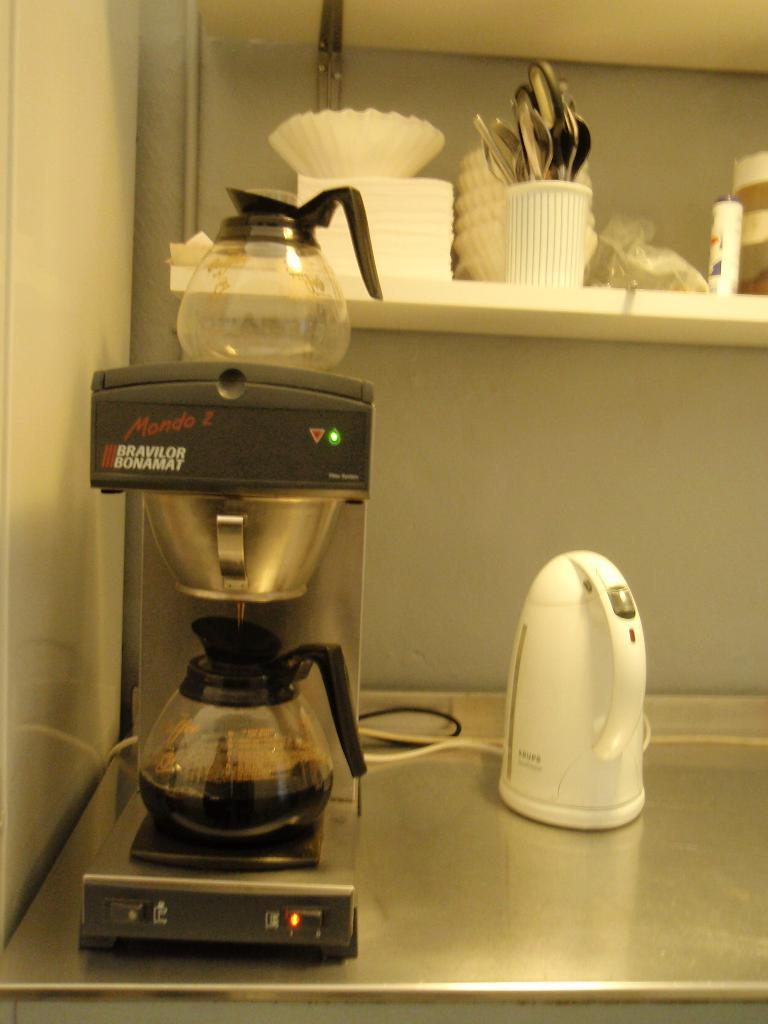<image>
Create a compact narrative representing the image presented. A bravilor bonamat coffee maker brews a pot of coffee 